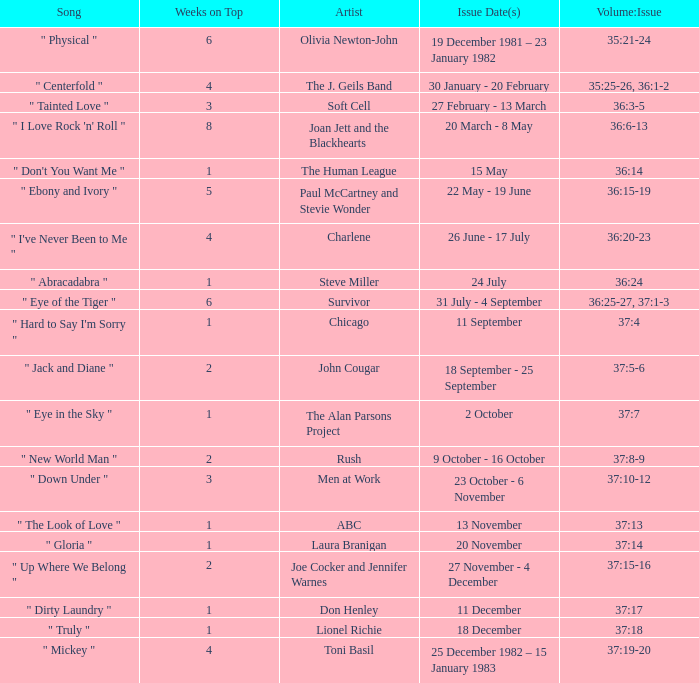Which issue date(s) includes an artist illustrating men at work? 23 October - 6 November. 